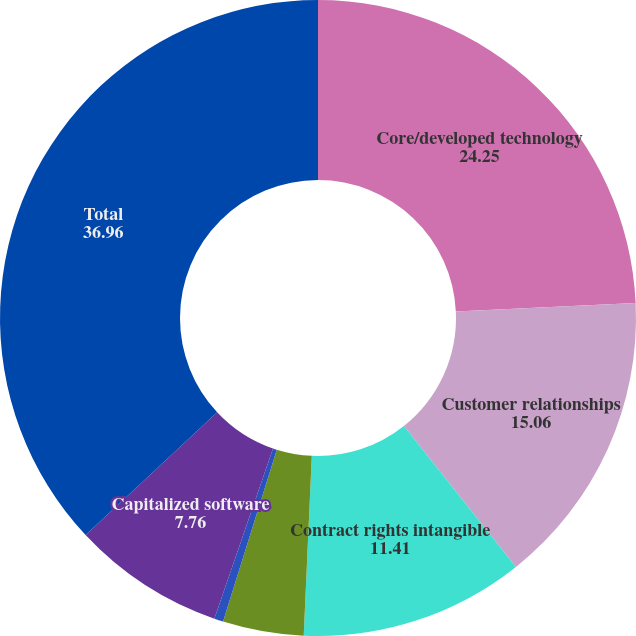Convert chart to OTSL. <chart><loc_0><loc_0><loc_500><loc_500><pie_chart><fcel>Core/developed technology<fcel>Customer relationships<fcel>Contract rights intangible<fcel>Covenants not to compete<fcel>Trademarks and trade names<fcel>Capitalized software<fcel>Total<nl><fcel>24.25%<fcel>15.06%<fcel>11.41%<fcel>4.11%<fcel>0.46%<fcel>7.76%<fcel>36.96%<nl></chart> 